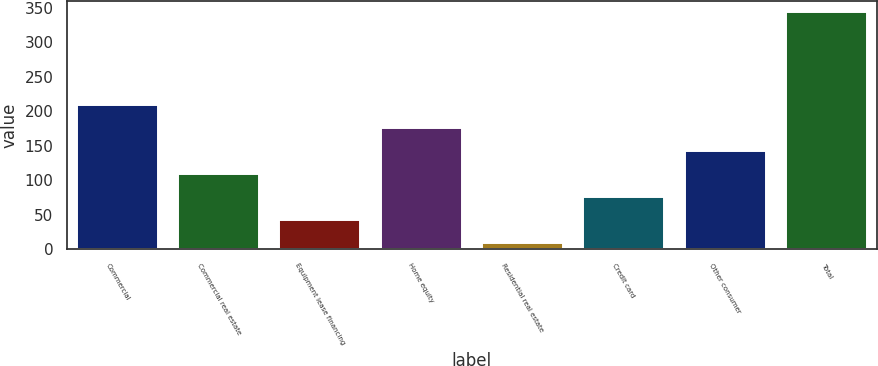Convert chart to OTSL. <chart><loc_0><loc_0><loc_500><loc_500><bar_chart><fcel>Commercial<fcel>Commercial real estate<fcel>Equipment lease financing<fcel>Home equity<fcel>Residential real estate<fcel>Credit card<fcel>Other consumer<fcel>Total<nl><fcel>209.4<fcel>109.2<fcel>42.4<fcel>176<fcel>9<fcel>75.8<fcel>142.6<fcel>343<nl></chart> 